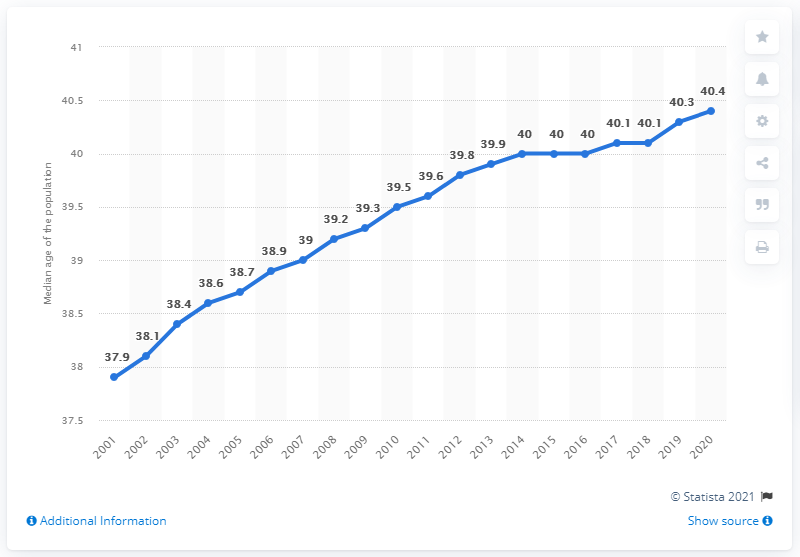Point out several critical features in this image. The highest point in the graph is 2.5, while the lowest point is also 2.5. The median age is expected to reach its peak in the year 2020. 